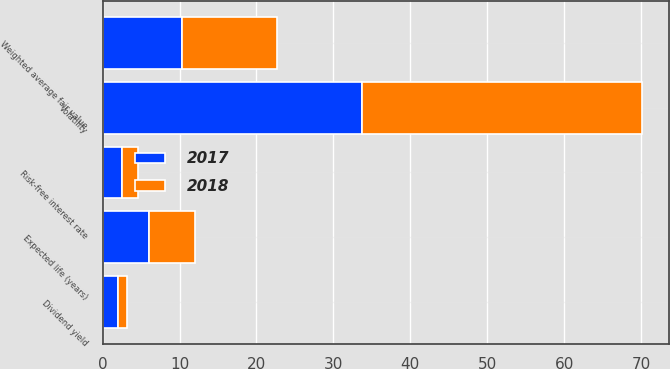Convert chart. <chart><loc_0><loc_0><loc_500><loc_500><stacked_bar_chart><ecel><fcel>Expected life (years)<fcel>Risk-free interest rate<fcel>Volatility<fcel>Dividend yield<fcel>Weighted average fair value<nl><fcel>2017<fcel>6<fcel>2.5<fcel>33.7<fcel>2<fcel>10.34<nl><fcel>2018<fcel>6<fcel>2.1<fcel>36.4<fcel>1.2<fcel>12.32<nl></chart> 